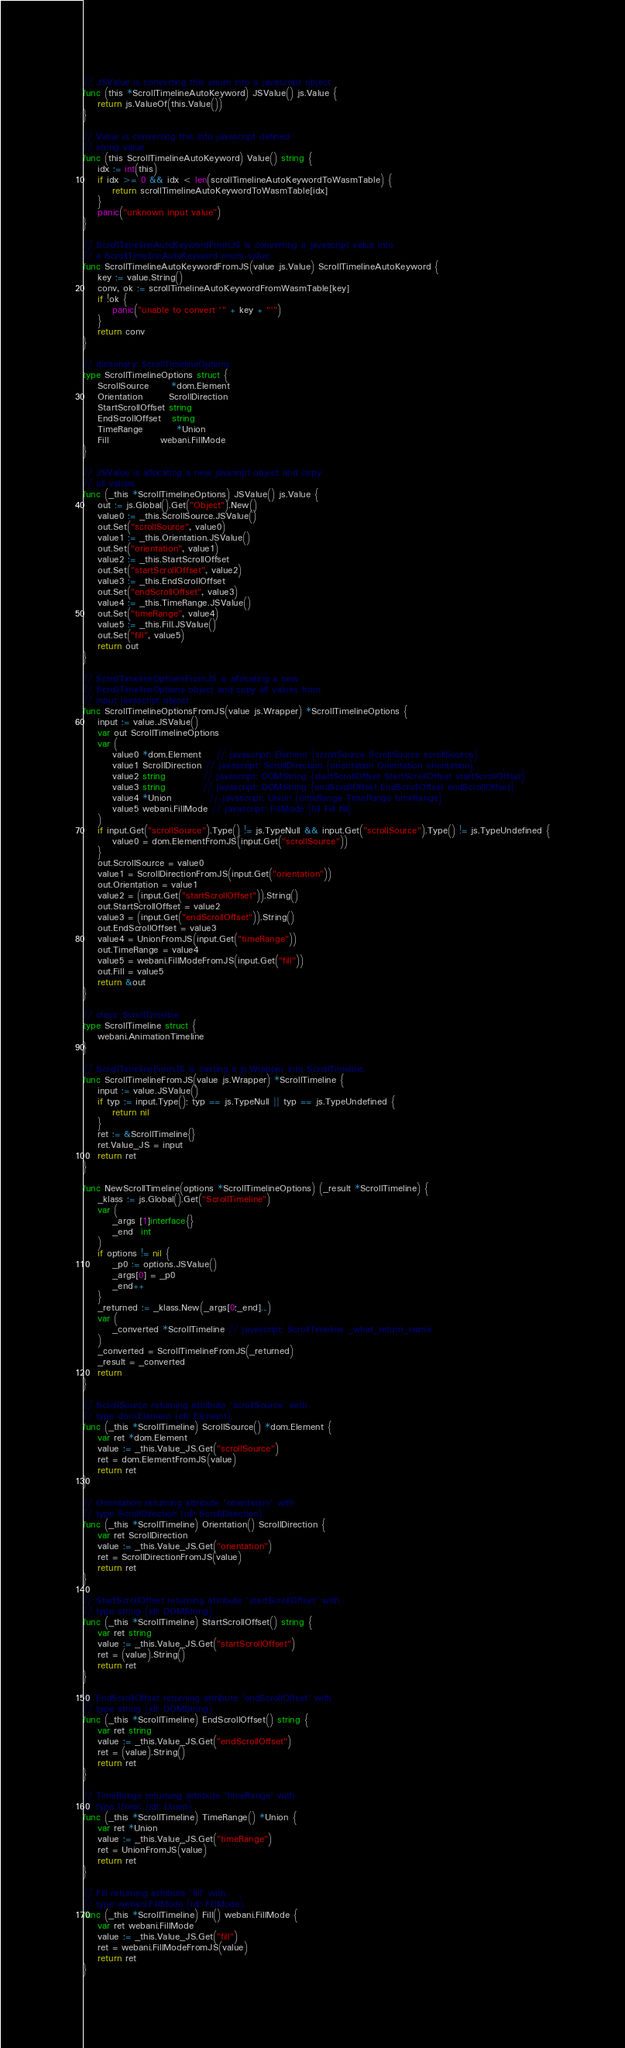Convert code to text. <code><loc_0><loc_0><loc_500><loc_500><_Go_>// JSValue is converting this enum into a javascript object
func (this *ScrollTimelineAutoKeyword) JSValue() js.Value {
	return js.ValueOf(this.Value())
}

// Value is converting this into javascript defined
// string value
func (this ScrollTimelineAutoKeyword) Value() string {
	idx := int(this)
	if idx >= 0 && idx < len(scrollTimelineAutoKeywordToWasmTable) {
		return scrollTimelineAutoKeywordToWasmTable[idx]
	}
	panic("unknown input value")
}

// ScrollTimelineAutoKeywordFromJS is converting a javascript value into
// a ScrollTimelineAutoKeyword enum value.
func ScrollTimelineAutoKeywordFromJS(value js.Value) ScrollTimelineAutoKeyword {
	key := value.String()
	conv, ok := scrollTimelineAutoKeywordFromWasmTable[key]
	if !ok {
		panic("unable to convert '" + key + "'")
	}
	return conv
}

// dictionary: ScrollTimelineOptions
type ScrollTimelineOptions struct {
	ScrollSource      *dom.Element
	Orientation       ScrollDirection
	StartScrollOffset string
	EndScrollOffset   string
	TimeRange         *Union
	Fill              webani.FillMode
}

// JSValue is allocating a new javasript object and copy
// all values
func (_this *ScrollTimelineOptions) JSValue() js.Value {
	out := js.Global().Get("Object").New()
	value0 := _this.ScrollSource.JSValue()
	out.Set("scrollSource", value0)
	value1 := _this.Orientation.JSValue()
	out.Set("orientation", value1)
	value2 := _this.StartScrollOffset
	out.Set("startScrollOffset", value2)
	value3 := _this.EndScrollOffset
	out.Set("endScrollOffset", value3)
	value4 := _this.TimeRange.JSValue()
	out.Set("timeRange", value4)
	value5 := _this.Fill.JSValue()
	out.Set("fill", value5)
	return out
}

// ScrollTimelineOptionsFromJS is allocating a new
// ScrollTimelineOptions object and copy all values from
// input javascript object
func ScrollTimelineOptionsFromJS(value js.Wrapper) *ScrollTimelineOptions {
	input := value.JSValue()
	var out ScrollTimelineOptions
	var (
		value0 *dom.Element    // javascript: Element {scrollSource ScrollSource scrollSource}
		value1 ScrollDirection // javascript: ScrollDirection {orientation Orientation orientation}
		value2 string          // javascript: DOMString {startScrollOffset StartScrollOffset startScrollOffset}
		value3 string          // javascript: DOMString {endScrollOffset EndScrollOffset endScrollOffset}
		value4 *Union          // javascript: Union {timeRange TimeRange timeRange}
		value5 webani.FillMode // javascript: FillMode {fill Fill fill}
	)
	if input.Get("scrollSource").Type() != js.TypeNull && input.Get("scrollSource").Type() != js.TypeUndefined {
		value0 = dom.ElementFromJS(input.Get("scrollSource"))
	}
	out.ScrollSource = value0
	value1 = ScrollDirectionFromJS(input.Get("orientation"))
	out.Orientation = value1
	value2 = (input.Get("startScrollOffset")).String()
	out.StartScrollOffset = value2
	value3 = (input.Get("endScrollOffset")).String()
	out.EndScrollOffset = value3
	value4 = UnionFromJS(input.Get("timeRange"))
	out.TimeRange = value4
	value5 = webani.FillModeFromJS(input.Get("fill"))
	out.Fill = value5
	return &out
}

// class: ScrollTimeline
type ScrollTimeline struct {
	webani.AnimationTimeline
}

// ScrollTimelineFromJS is casting a js.Wrapper into ScrollTimeline.
func ScrollTimelineFromJS(value js.Wrapper) *ScrollTimeline {
	input := value.JSValue()
	if typ := input.Type(); typ == js.TypeNull || typ == js.TypeUndefined {
		return nil
	}
	ret := &ScrollTimeline{}
	ret.Value_JS = input
	return ret
}

func NewScrollTimeline(options *ScrollTimelineOptions) (_result *ScrollTimeline) {
	_klass := js.Global().Get("ScrollTimeline")
	var (
		_args [1]interface{}
		_end  int
	)
	if options != nil {
		_p0 := options.JSValue()
		_args[0] = _p0
		_end++
	}
	_returned := _klass.New(_args[0:_end]...)
	var (
		_converted *ScrollTimeline // javascript: ScrollTimeline _what_return_name
	)
	_converted = ScrollTimelineFromJS(_returned)
	_result = _converted
	return
}

// ScrollSource returning attribute 'scrollSource' with
// type dom.Element (idl: Element).
func (_this *ScrollTimeline) ScrollSource() *dom.Element {
	var ret *dom.Element
	value := _this.Value_JS.Get("scrollSource")
	ret = dom.ElementFromJS(value)
	return ret
}

// Orientation returning attribute 'orientation' with
// type ScrollDirection (idl: ScrollDirection).
func (_this *ScrollTimeline) Orientation() ScrollDirection {
	var ret ScrollDirection
	value := _this.Value_JS.Get("orientation")
	ret = ScrollDirectionFromJS(value)
	return ret
}

// StartScrollOffset returning attribute 'startScrollOffset' with
// type string (idl: DOMString).
func (_this *ScrollTimeline) StartScrollOffset() string {
	var ret string
	value := _this.Value_JS.Get("startScrollOffset")
	ret = (value).String()
	return ret
}

// EndScrollOffset returning attribute 'endScrollOffset' with
// type string (idl: DOMString).
func (_this *ScrollTimeline) EndScrollOffset() string {
	var ret string
	value := _this.Value_JS.Get("endScrollOffset")
	ret = (value).String()
	return ret
}

// TimeRange returning attribute 'timeRange' with
// type Union (idl: Union).
func (_this *ScrollTimeline) TimeRange() *Union {
	var ret *Union
	value := _this.Value_JS.Get("timeRange")
	ret = UnionFromJS(value)
	return ret
}

// Fill returning attribute 'fill' with
// type webani.FillMode (idl: FillMode).
func (_this *ScrollTimeline) Fill() webani.FillMode {
	var ret webani.FillMode
	value := _this.Value_JS.Get("fill")
	ret = webani.FillModeFromJS(value)
	return ret
}
</code> 